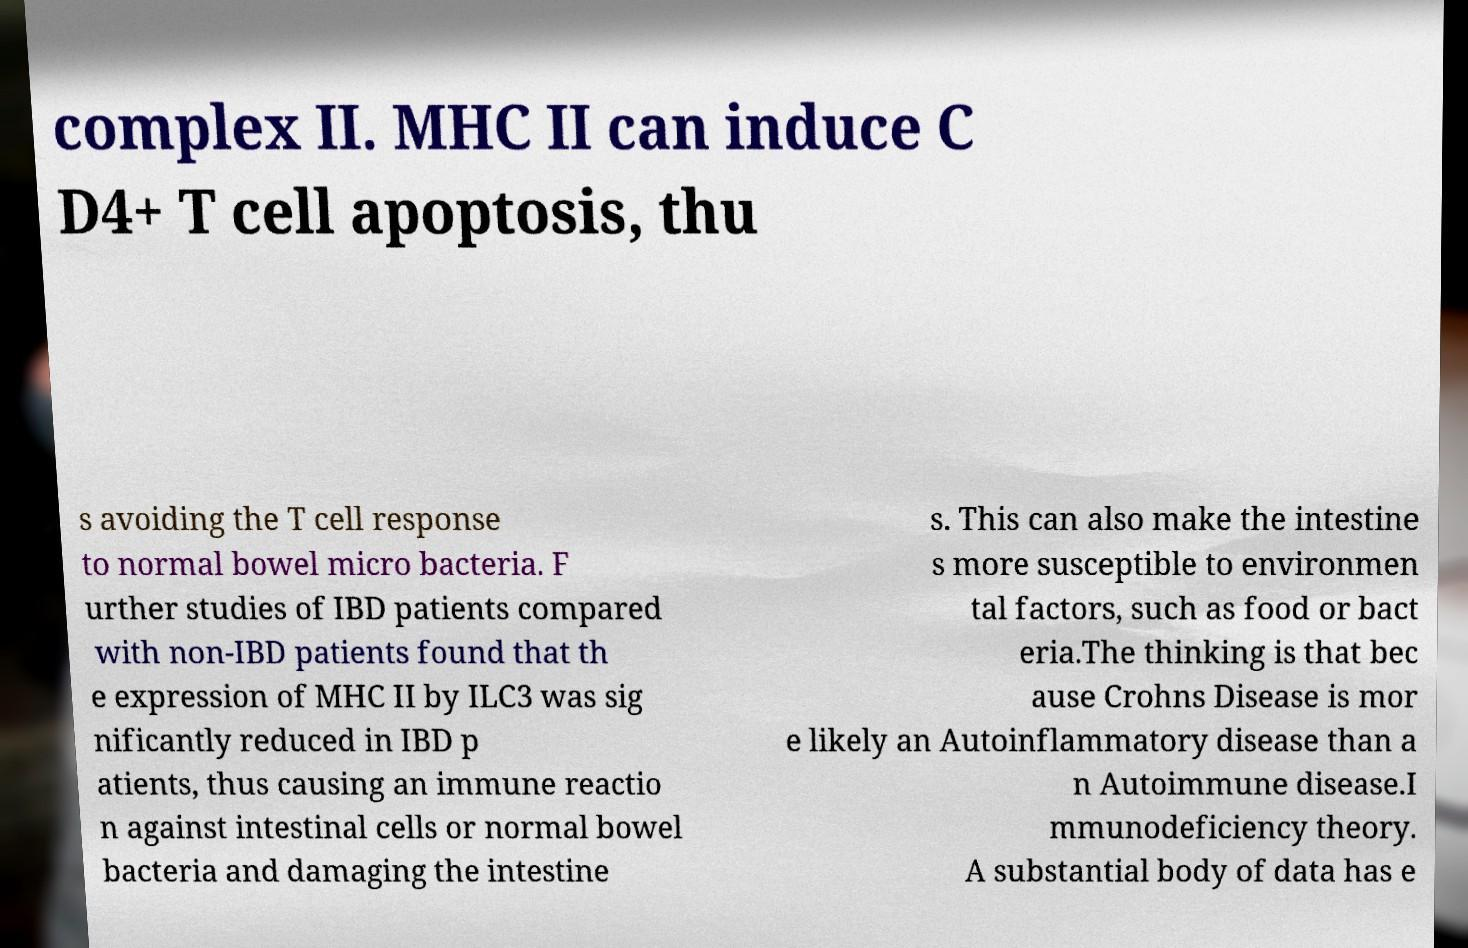I need the written content from this picture converted into text. Can you do that? complex II. MHC II can induce C D4+ T cell apoptosis, thu s avoiding the T cell response to normal bowel micro bacteria. F urther studies of IBD patients compared with non-IBD patients found that th e expression of MHC II by ILC3 was sig nificantly reduced in IBD p atients, thus causing an immune reactio n against intestinal cells or normal bowel bacteria and damaging the intestine s. This can also make the intestine s more susceptible to environmen tal factors, such as food or bact eria.The thinking is that bec ause Crohns Disease is mor e likely an Autoinflammatory disease than a n Autoimmune disease.I mmunodeficiency theory. A substantial body of data has e 